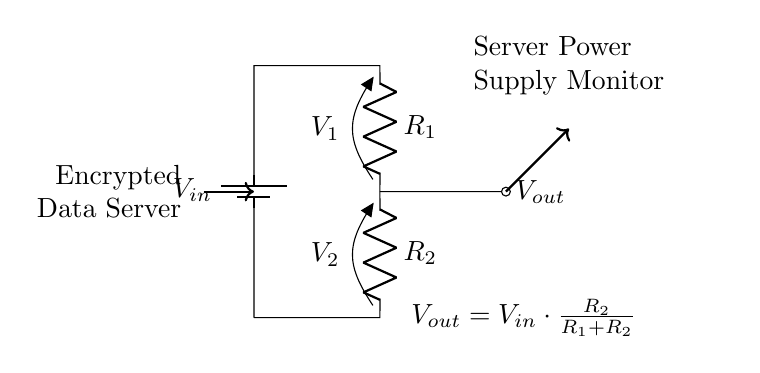What is the input voltage indicated in the circuit? The input voltage is denoted by \( V_{in} \) and is represented by the battery symbol in the circuit.
Answer: \( V_{in} \) What are the resistance values in the voltage divider? The resistances are represented as \( R_1 \) and \( R_2 \) in the circuit diagram, which are specified next to the respective resistors.
Answer: \( R_1 \) and \( R_2 \) What is the output voltage equation for this circuit? The output voltage equation is shown in the description near \( V_{out} \) and calculates the output based on the input and the resistors. It is expressed as \( V_{out} = V_{in} \cdot \frac{R_2}{R_1 + R_2} \).
Answer: \( V_{out} = V_{in} \cdot \frac{R_2}{R_1 + R_2} \) How does increasing \( R_2 \) affect \( V_{out} \)? Increasing \( R_2 \) while keeping \( R_1 \) constant raises the value of \( \frac{R_2}{R_1 + R_2} \), thereby increasing \( V_{out} \) according to the voltage divider formula.
Answer: Increases \( V_{out} \) What is the function of this voltage divider circuit? This circuit is used to monitor the power supply voltages of the server by providing a scaled-down version of the input voltage, which can be safely measured.
Answer: Voltage monitoring In this circuit, where is the output voltage taken from? The output voltage \( V_{out} \) is taken from the node between resistors \( R_1 \) and \( R_2 \), which is indicated by an outgoing arrow to the right.
Answer: Between \( R_1 \) and \( R_2 \) 